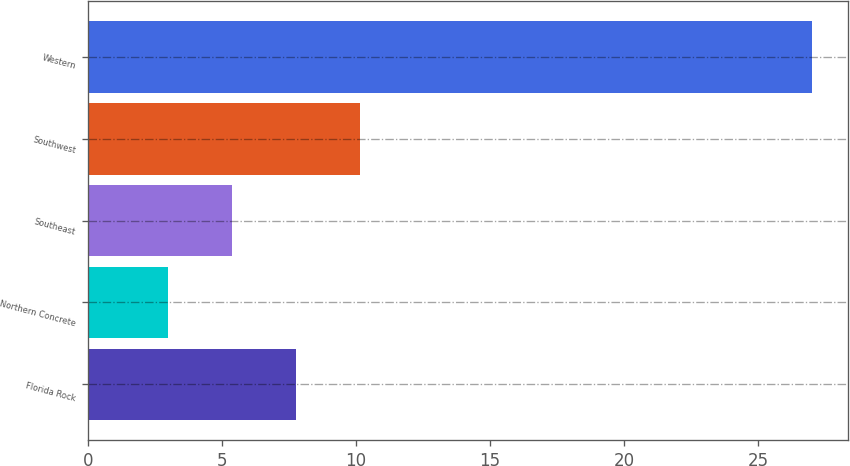Convert chart to OTSL. <chart><loc_0><loc_0><loc_500><loc_500><bar_chart><fcel>Florida Rock<fcel>Northern Concrete<fcel>Southeast<fcel>Southwest<fcel>Western<nl><fcel>7.76<fcel>2.96<fcel>5.36<fcel>10.16<fcel>27<nl></chart> 